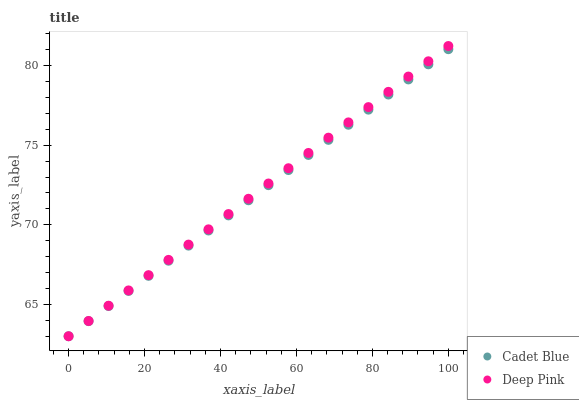Does Cadet Blue have the minimum area under the curve?
Answer yes or no. Yes. Does Deep Pink have the maximum area under the curve?
Answer yes or no. Yes. Does Deep Pink have the minimum area under the curve?
Answer yes or no. No. Is Cadet Blue the smoothest?
Answer yes or no. Yes. Is Deep Pink the roughest?
Answer yes or no. Yes. Is Deep Pink the smoothest?
Answer yes or no. No. Does Cadet Blue have the lowest value?
Answer yes or no. Yes. Does Deep Pink have the highest value?
Answer yes or no. Yes. Does Deep Pink intersect Cadet Blue?
Answer yes or no. Yes. Is Deep Pink less than Cadet Blue?
Answer yes or no. No. Is Deep Pink greater than Cadet Blue?
Answer yes or no. No. 